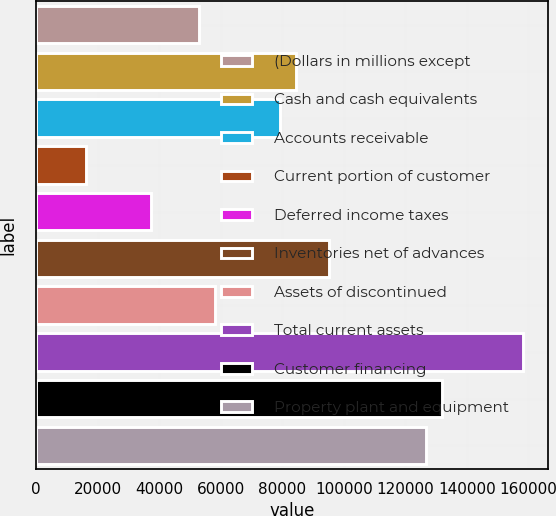Convert chart. <chart><loc_0><loc_0><loc_500><loc_500><bar_chart><fcel>(Dollars in millions except<fcel>Cash and cash equivalents<fcel>Accounts receivable<fcel>Current portion of customer<fcel>Deferred income taxes<fcel>Inventories net of advances<fcel>Assets of discontinued<fcel>Total current assets<fcel>Customer financing<fcel>Property plant and equipment<nl><fcel>52986<fcel>84611.4<fcel>79340.5<fcel>16089.7<fcel>37173.3<fcel>95153.2<fcel>58256.9<fcel>158404<fcel>132050<fcel>126779<nl></chart> 